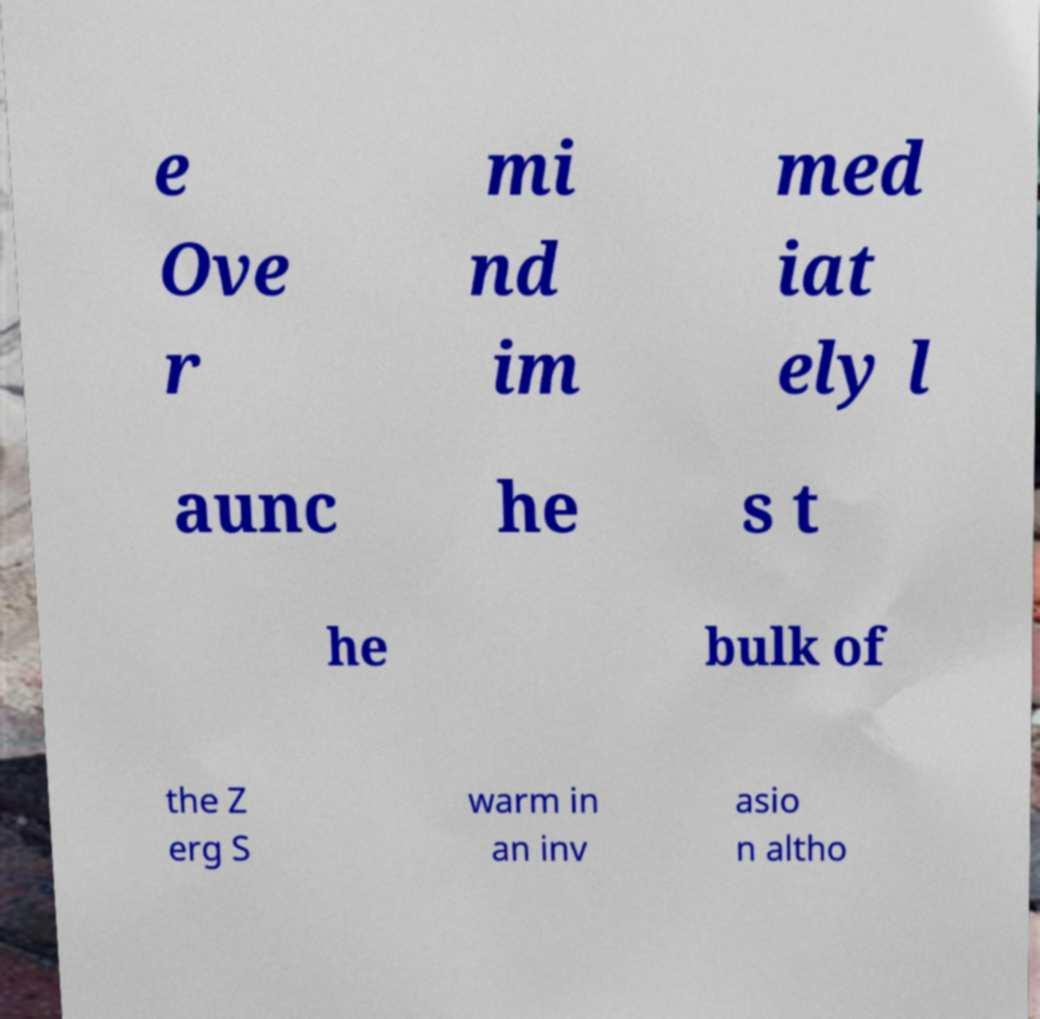Can you accurately transcribe the text from the provided image for me? e Ove r mi nd im med iat ely l aunc he s t he bulk of the Z erg S warm in an inv asio n altho 